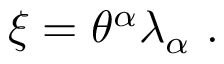<formula> <loc_0><loc_0><loc_500><loc_500>\xi = \theta ^ { \alpha } \lambda _ { \alpha } \ .</formula> 